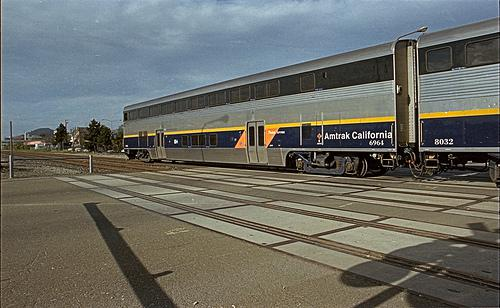Question: what is in the sky?
Choices:
A. Birds.
B. Kites.
C. Clouds.
D. Snow.
Answer with the letter. Answer: C Question: when is the train shown?
Choices:
A. Nighttime.
B. Early morning.
C. Daytime.
D. Sunset.
Answer with the letter. Answer: C Question: what state is written on the train?
Choices:
A. Minnesota.
B. California.
C. Arizona.
D. Alabama.
Answer with the letter. Answer: B 